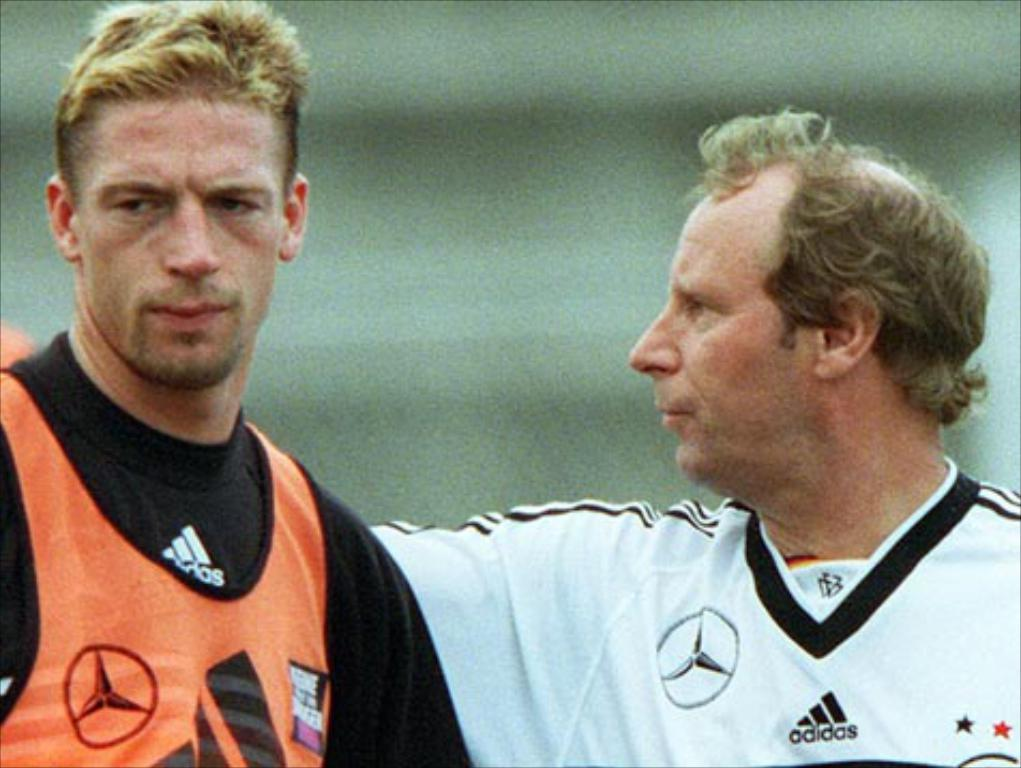<image>
Summarize the visual content of the image. Soccer players practicing a game sponsored by Adidas. 